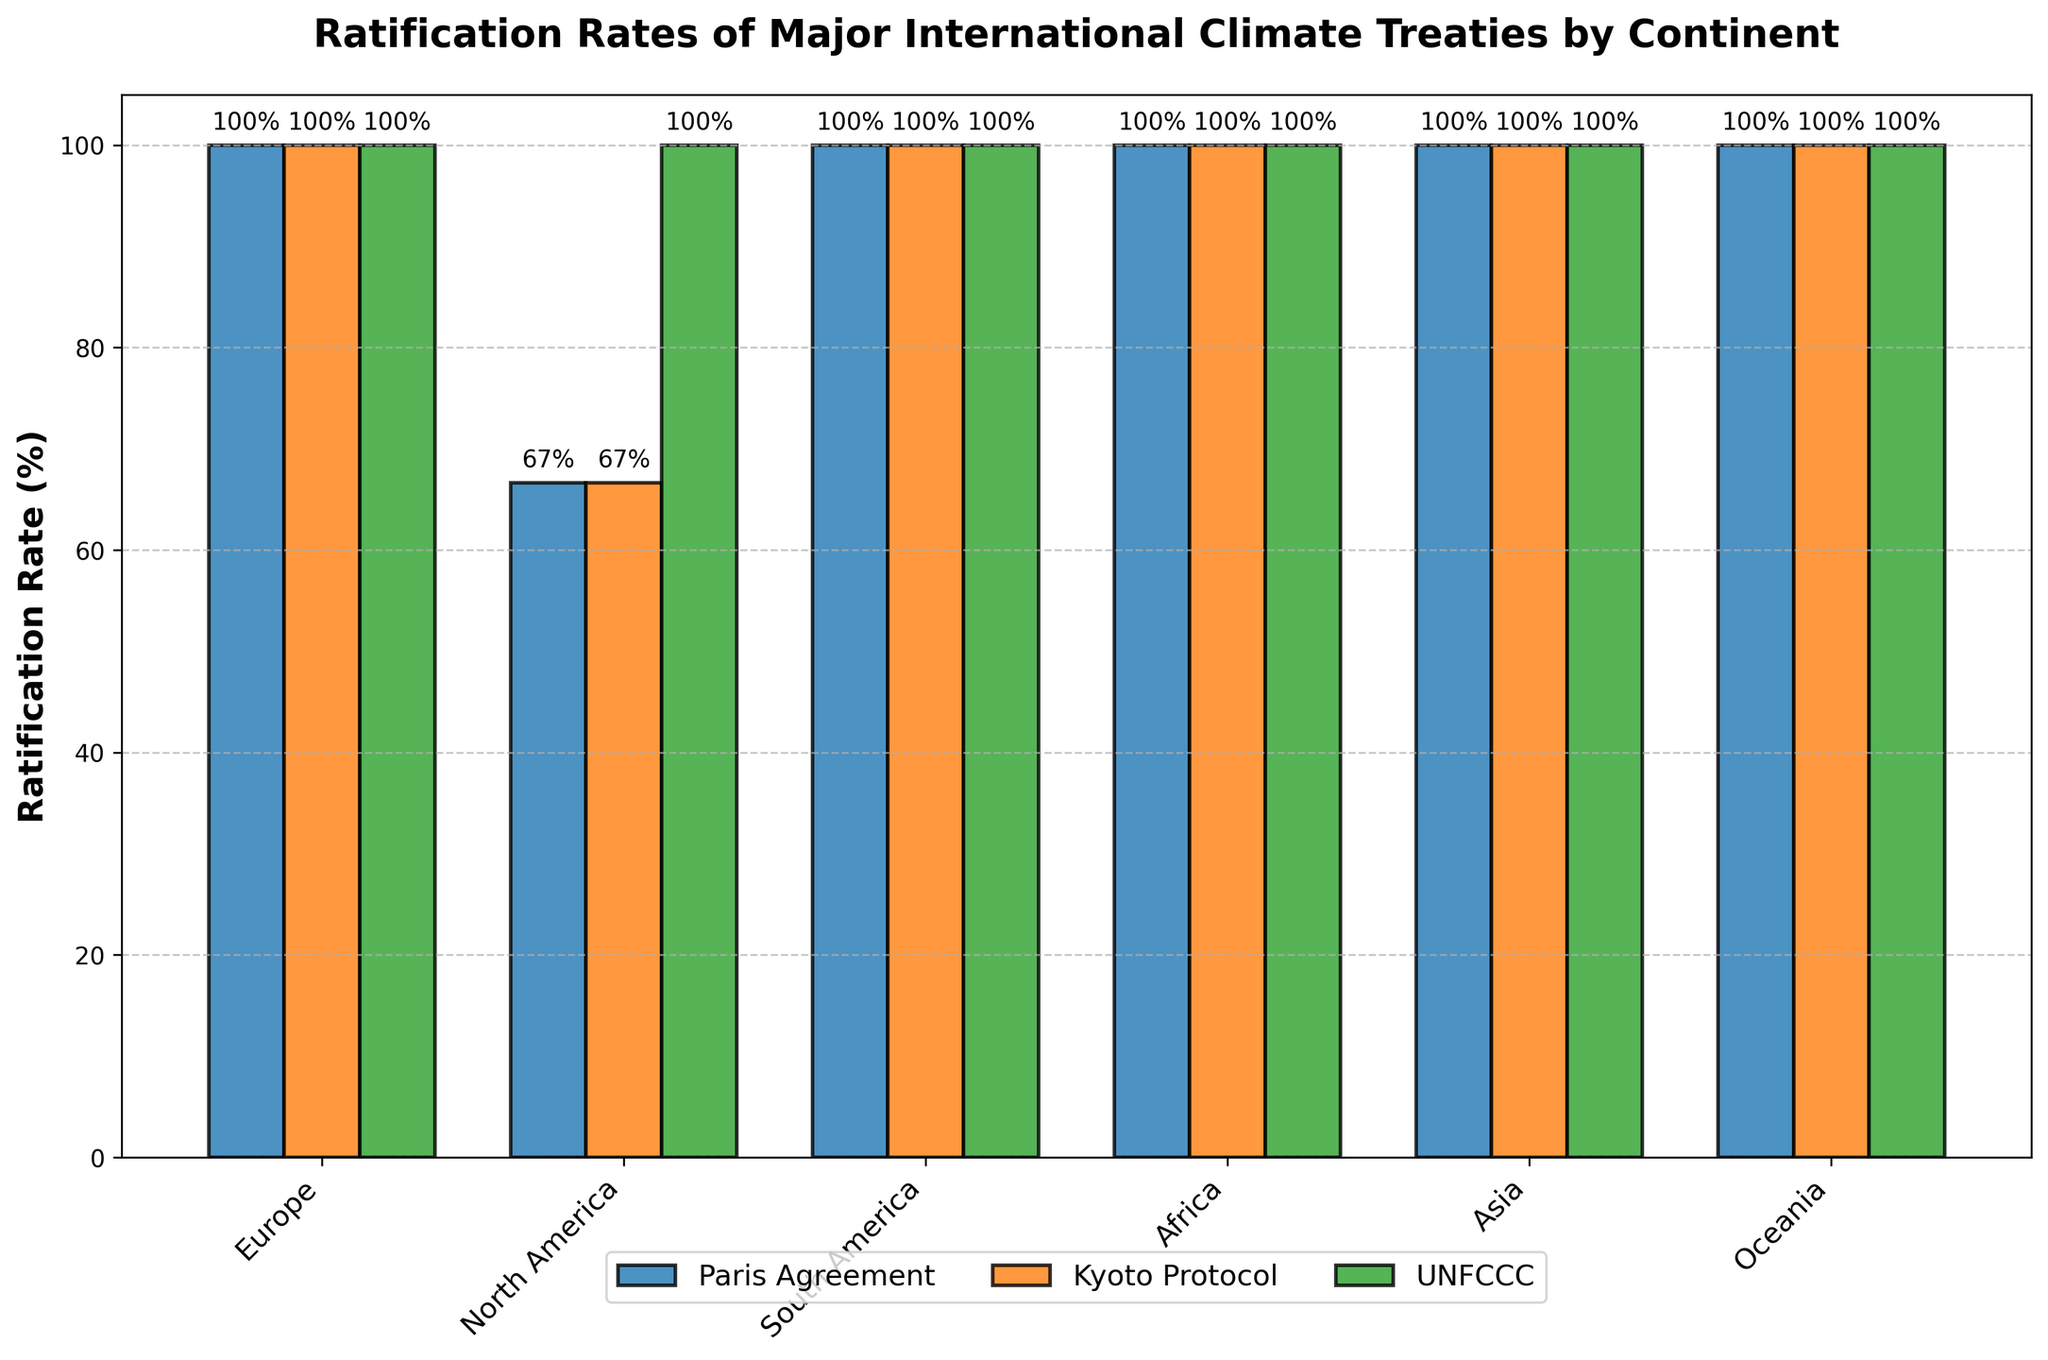Which continent shows a 100% ratification rate for all three treaties? The continent is evaluated that has 100% ratification across Paris Agreement, Kyoto Protocol, and UNFCCC. Since every continent displays at least one treaty with 100%, find the one where all three treaties have this value.
Answer: Europe Comparing the Paris Agreement and Kyoto Protocol, which continents have different ratification rates? Identify differences in bars for each continent between the Paris Agreement and Kyoto Protocol. Only North America shows a significant difference, indicating variance in rates. Paris Agreement = 66%, Kyoto Protocol = 66%. Other continents have all bars at 100%.
Answer: North America What's the combined average ratification rate of the Paris Agreement across all continents? Calculate the mean of the Paris Agreement percentages across each continent: Europe (100%), North America (66%), South America (100%), Africa (100%), Asia (100%), Oceania (100%). Sum (100 + 66 + 100 + 100 + 100 + 100) / 6 = 566 / 6 = 94.33%.
Answer: 94.33% Which continent has the lowest ratification rate for the Kyoto Protocol? Compare the height of the bars for the Kyoto Protocol among all continents. The lowest bar corresponds to North America (66%).
Answer: North America Is there any continent where the ratification rate for the UNFCCC is not 100%? Visually scan the UNFCCC bars across all continents. All bars are fully extended to 100%, indicating complete ratification.
Answer: No Which continent has the highest variability in ratification rates across all three treaties? Assess the differences in bar heights for each treaty per continent. North America shows variability with 66% for Paris Agreement and Kyoto Protocol and 100% for UNFCCC, indicating the highest variability.
Answer: North America What's the average ratification rate of the Kyoto Protocol in Africa and Asia? Combine average rates for Africa and Asia. Both have 100% in the Kyoto Protocol. (100 + 100) / 2 = 200 / 2 = 100%.
Answer: 100% Between developed countries in Oceania and North America, which has a higher average ratification rate for the Paris Agreement? Oceania has Australia and New Zealand with 100% each, and North America has the USA (0%) and Canada (100%). Oceania: (100 + 100) / 2 = 100%. North America: (0 + 100) / 2 = 50%. Oceania is higher.
Answer: Oceania What is the difference in ratification rates for the Kyoto Protocol between developed and developing countries in Asia? Asia's developed country (Japan) and developing countries (China and India) all show 100% ratification for Kyoto Protocol, indicating no difference.
Answer: 0% How does the ratification rate for the Paris Agreement in South America compare to that in North America? Compare bar heights: South America shows 100% for Paris Agreement, while North America shows 66%. Therefore, South America has a higher rate.
Answer: South America 